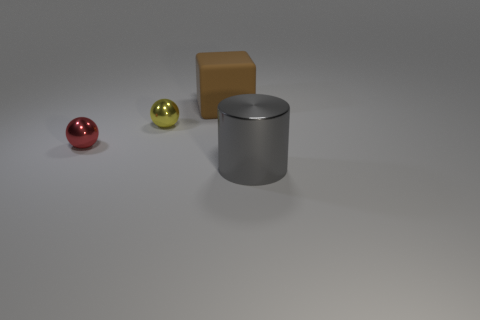Is there anything else that has the same material as the block?
Provide a short and direct response. No. What number of gray shiny objects are the same size as the brown object?
Give a very brief answer. 1. There is a shiny cylinder; does it have the same size as the sphere that is behind the small red shiny sphere?
Provide a short and direct response. No. What number of objects are yellow cylinders or gray cylinders?
Offer a very short reply. 1. How many metal balls are the same color as the large shiny thing?
Make the answer very short. 0. The brown thing that is the same size as the gray cylinder is what shape?
Your answer should be very brief. Cube. Is there another purple object of the same shape as the matte thing?
Make the answer very short. No. What number of tiny yellow balls are the same material as the red sphere?
Your answer should be very brief. 1. Does the sphere on the right side of the red metallic thing have the same material as the cube?
Provide a succinct answer. No. Is the number of tiny yellow shiny balls behind the brown block greater than the number of things that are in front of the red ball?
Provide a short and direct response. No. 